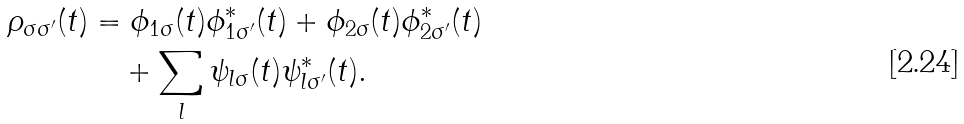Convert formula to latex. <formula><loc_0><loc_0><loc_500><loc_500>\rho _ { \sigma \sigma ^ { \prime } } ( t ) & = \phi _ { 1 \sigma } ( t ) \phi _ { 1 \sigma ^ { \prime } } ^ { \ast } ( t ) + \phi _ { 2 \sigma } ( t ) \phi _ { 2 \sigma ^ { \prime } } ^ { \ast } ( t ) \\ & \quad + \sum _ { l } \psi _ { l \sigma } ( t ) \psi _ { l \sigma ^ { \prime } } ^ { \ast } ( t ) .</formula> 